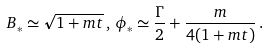Convert formula to latex. <formula><loc_0><loc_0><loc_500><loc_500>B _ { * } \simeq \sqrt { 1 + m t } \, , \, \phi _ { * } \simeq \frac { \Gamma } { 2 } + \frac { m } { 4 ( 1 + m t ) } \, .</formula> 